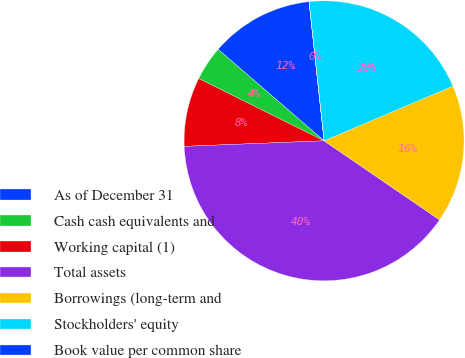Convert chart to OTSL. <chart><loc_0><loc_0><loc_500><loc_500><pie_chart><fcel>As of December 31<fcel>Cash cash equivalents and<fcel>Working capital (1)<fcel>Total assets<fcel>Borrowings (long-term and<fcel>Stockholders' equity<fcel>Book value per common share<nl><fcel>11.95%<fcel>3.99%<fcel>7.97%<fcel>39.81%<fcel>15.93%<fcel>20.32%<fcel>0.01%<nl></chart> 